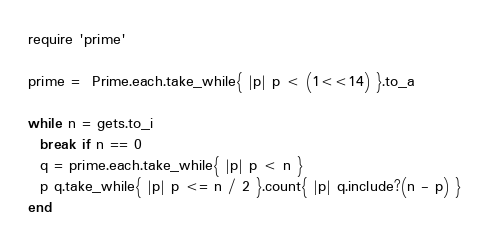Convert code to text. <code><loc_0><loc_0><loc_500><loc_500><_Ruby_>require 'prime'

prime =  Prime.each.take_while{ |p| p < (1<<14) }.to_a

while n = gets.to_i
  break if n == 0
  q = prime.each.take_while{ |p| p < n }
  p q.take_while{ |p| p <= n / 2 }.count{ |p| q.include?(n - p) }
end</code> 